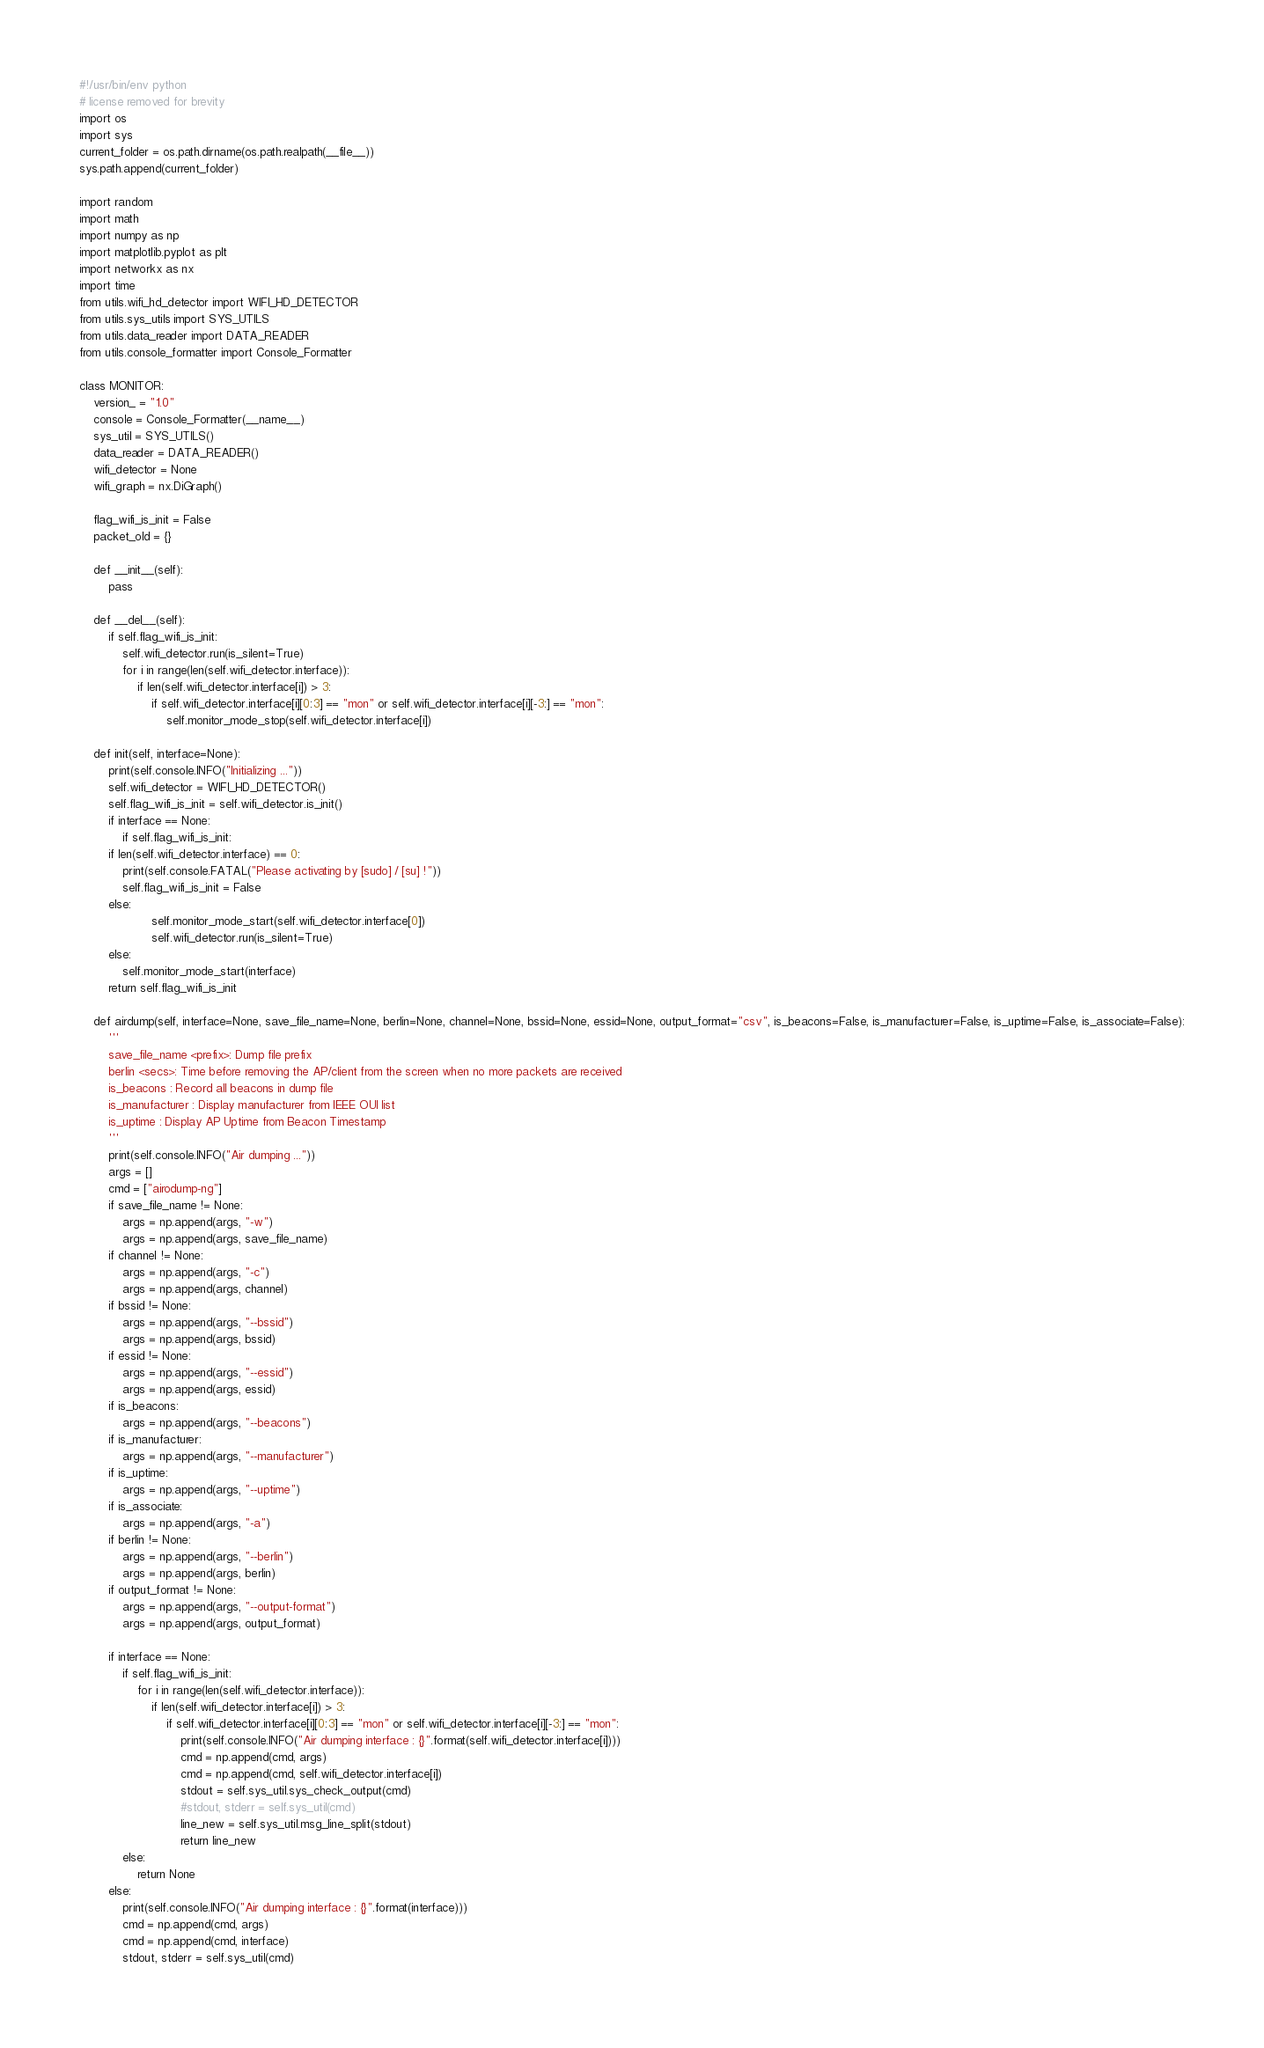Convert code to text. <code><loc_0><loc_0><loc_500><loc_500><_Python_>#!/usr/bin/env python
# license removed for brevity
import os
import sys
current_folder = os.path.dirname(os.path.realpath(__file__))
sys.path.append(current_folder)

import random
import math
import numpy as np
import matplotlib.pyplot as plt
import networkx as nx
import time
from utils.wifi_hd_detector import WIFI_HD_DETECTOR
from utils.sys_utils import SYS_UTILS
from utils.data_reader import DATA_READER
from utils.console_formatter import Console_Formatter

class MONITOR:
    version_ = "1.0"
    console = Console_Formatter(__name__)
    sys_util = SYS_UTILS()
    data_reader = DATA_READER()
    wifi_detector = None
    wifi_graph = nx.DiGraph()
    
    flag_wifi_is_init = False
    packet_old = {}
    
    def __init__(self):
        pass
        
    def __del__(self):
        if self.flag_wifi_is_init:
            self.wifi_detector.run(is_silent=True)
            for i in range(len(self.wifi_detector.interface)):
                if len(self.wifi_detector.interface[i]) > 3:
                    if self.wifi_detector.interface[i][0:3] == "mon" or self.wifi_detector.interface[i][-3:] == "mon":
                        self.monitor_mode_stop(self.wifi_detector.interface[i])
                    
    def init(self, interface=None):
        print(self.console.INFO("Initializing ..."))
        self.wifi_detector = WIFI_HD_DETECTOR()
        self.flag_wifi_is_init = self.wifi_detector.is_init()
        if interface == None:
            if self.flag_wifi_is_init:
		if len(self.wifi_detector.interface) == 0:
		    print(self.console.FATAL("Please activating by [sudo] / [su] !"))
		    self.flag_wifi_is_init = False
		else:
                    self.monitor_mode_start(self.wifi_detector.interface[0])
                    self.wifi_detector.run(is_silent=True)
        else:
            self.monitor_mode_start(interface)
        return self.flag_wifi_is_init

    def airdump(self, interface=None, save_file_name=None, berlin=None, channel=None, bssid=None, essid=None, output_format="csv", is_beacons=False, is_manufacturer=False, is_uptime=False, is_associate=False):
        '''
        save_file_name <prefix>: Dump file prefix
        berlin <secs>: Time before removing the AP/client from the screen when no more packets are received
        is_beacons : Record all beacons in dump file
        is_manufacturer : Display manufacturer from IEEE OUI list
        is_uptime : Display AP Uptime from Beacon Timestamp
        '''
        print(self.console.INFO("Air dumping ..."))
        args = []
        cmd = ["airodump-ng"]
        if save_file_name != None:
            args = np.append(args, "-w")
            args = np.append(args, save_file_name)
        if channel != None:
            args = np.append(args, "-c")
            args = np.append(args, channel)
        if bssid != None:
            args = np.append(args, "--bssid")
            args = np.append(args, bssid)
        if essid != None:
            args = np.append(args, "--essid")
            args = np.append(args, essid)
        if is_beacons:
            args = np.append(args, "--beacons")
        if is_manufacturer:
            args = np.append(args, "--manufacturer")
        if is_uptime:
            args = np.append(args, "--uptime")
        if is_associate:
            args = np.append(args, "-a")
        if berlin != None:
            args = np.append(args, "--berlin")
            args = np.append(args, berlin)
        if output_format != None:
            args = np.append(args, "--output-format")
            args = np.append(args, output_format)
            
        if interface == None:
            if self.flag_wifi_is_init:
                for i in range(len(self.wifi_detector.interface)):
                    if len(self.wifi_detector.interface[i]) > 3:
                        if self.wifi_detector.interface[i][0:3] == "mon" or self.wifi_detector.interface[i][-3:] == "mon":
                            print(self.console.INFO("Air dumping interface : {}".format(self.wifi_detector.interface[i])))
                            cmd = np.append(cmd, args)
                            cmd = np.append(cmd, self.wifi_detector.interface[i])
                            stdout = self.sys_util.sys_check_output(cmd)
                            #stdout, stderr = self.sys_util(cmd)
                            line_new = self.sys_util.msg_line_split(stdout)
                            return line_new
            else:
                return None
        else:
            print(self.console.INFO("Air dumping interface : {}".format(interface)))
            cmd = np.append(cmd, args)
            cmd = np.append(cmd, interface)
            stdout, stderr = self.sys_util(cmd)</code> 